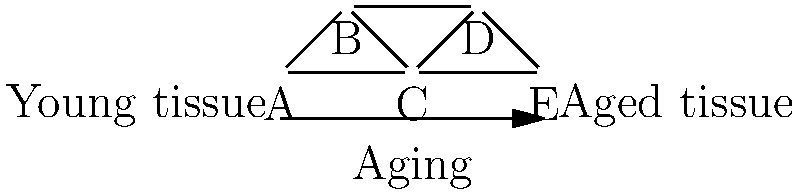In the protein network topology shown above, representing the changes in connectivity from young to aged tissue, what is the clustering coefficient of node C, and how does this relate to the overall network resilience in aging tissues? To answer this question, we need to follow these steps:

1. Understand the clustering coefficient:
   The clustering coefficient measures how interconnected a node's neighbors are. It's calculated as the ratio of existing connections between neighbors to the total possible connections.

2. Identify node C's neighbors:
   Node C is connected to nodes A, B, D, and E.

3. Count existing connections between C's neighbors:
   A-B: Connected
   B-D: Connected
   D-E: Connected
   A-E: Not connected

4. Calculate the clustering coefficient:
   - Total possible connections: $\binom{4}{2} = 6$
   - Existing connections: 3
   - Clustering coefficient = $\frac{3}{6} = 0.5$

5. Interpret the result in the context of aging:
   A clustering coefficient of 0.5 indicates moderate local connectivity. In aging tissues, this suggests:
   
   a) Partial preservation of local network structure
   b) Some loss of connections compared to a fully connected local network
   c) Potential for reduced network resilience, as fewer alternative pathways exist

6. Relate to overall network resilience:
   - Higher clustering coefficients generally indicate greater local redundancy and robustness.
   - The moderate value (0.5) suggests that while some local connectivity is maintained, there's a risk of decreased network resilience with aging.
   - This aligns with the "network theory of aging," which posits that age-related cellular dysfunction partly results from a loss of network complexity and robustness.
Answer: 0.5; indicates moderate local connectivity, suggesting partial network resilience preservation but potential vulnerability to further age-related deterioration. 